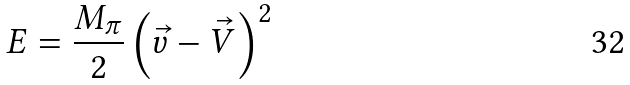Convert formula to latex. <formula><loc_0><loc_0><loc_500><loc_500>E = \frac { M _ { \pi } } { 2 } \left ( \vec { v } - \vec { V } \right ) ^ { 2 }</formula> 